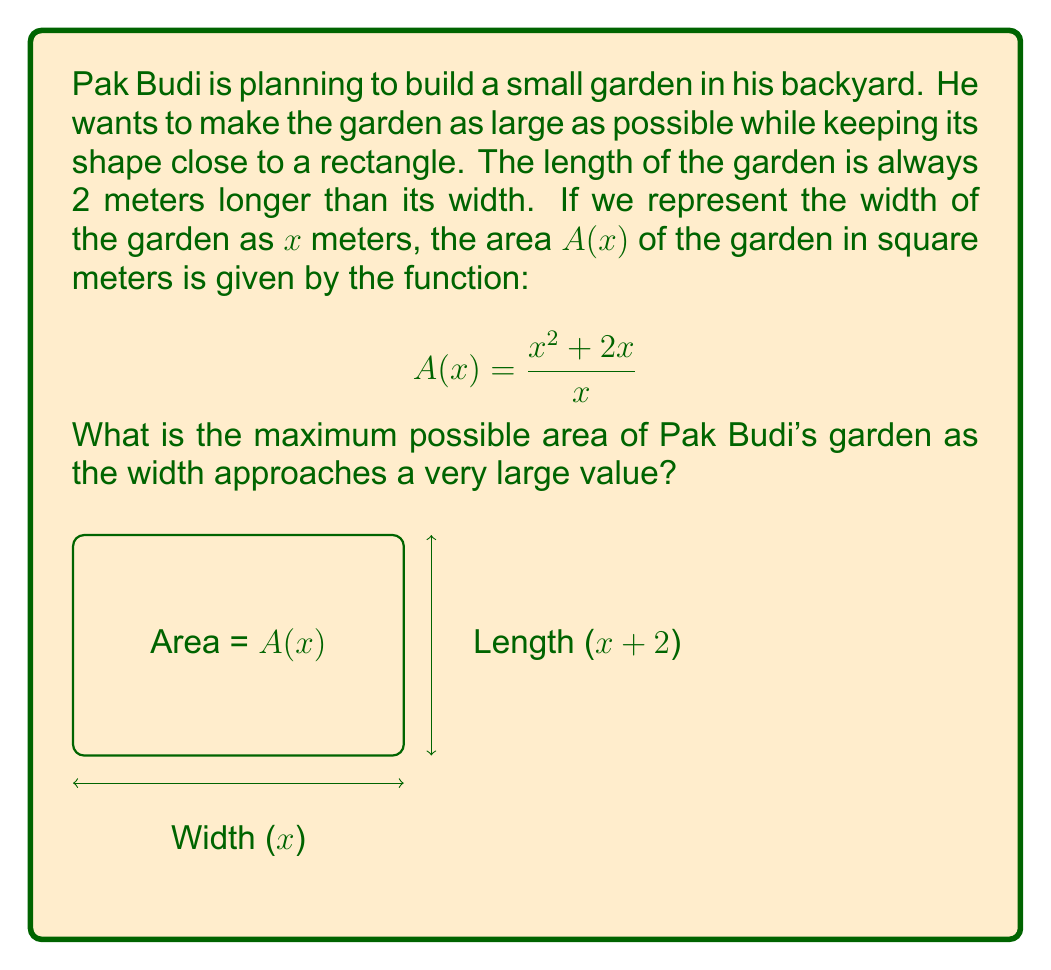What is the answer to this math problem? Let's approach this problem step-by-step:

1) We need to find the limit of $A(x)$ as $x$ approaches infinity. In mathematical notation:

   $$\lim_{x \to \infty} A(x) = \lim_{x \to \infty} \frac{x^2 + 2x}{x}$$

2) To solve this, let's divide both the numerator and denominator by the highest power of $x$ in the numerator, which is $x^2$:

   $$\lim_{x \to \infty} \frac{x^2 + 2x}{x} = \lim_{x \to \infty} \frac{\frac{x^2}{x^2} + \frac{2x}{x^2}}{\frac{x}{x^2}}$$

3) Simplify:

   $$\lim_{x \to \infty} \frac{1 + \frac{2}{x}}{\frac{1}{x}}$$

4) As $x$ approaches infinity, $\frac{1}{x}$ approaches 0:

   $$\lim_{x \to \infty} \frac{1 + 0}{0} = \frac{1}{0}$$

5) The limit of 1 divided by a number approaching 0 is infinity.

Therefore, as the width of the garden becomes very large, the area of the garden approaches infinity.
Answer: $\infty$ (infinity) 